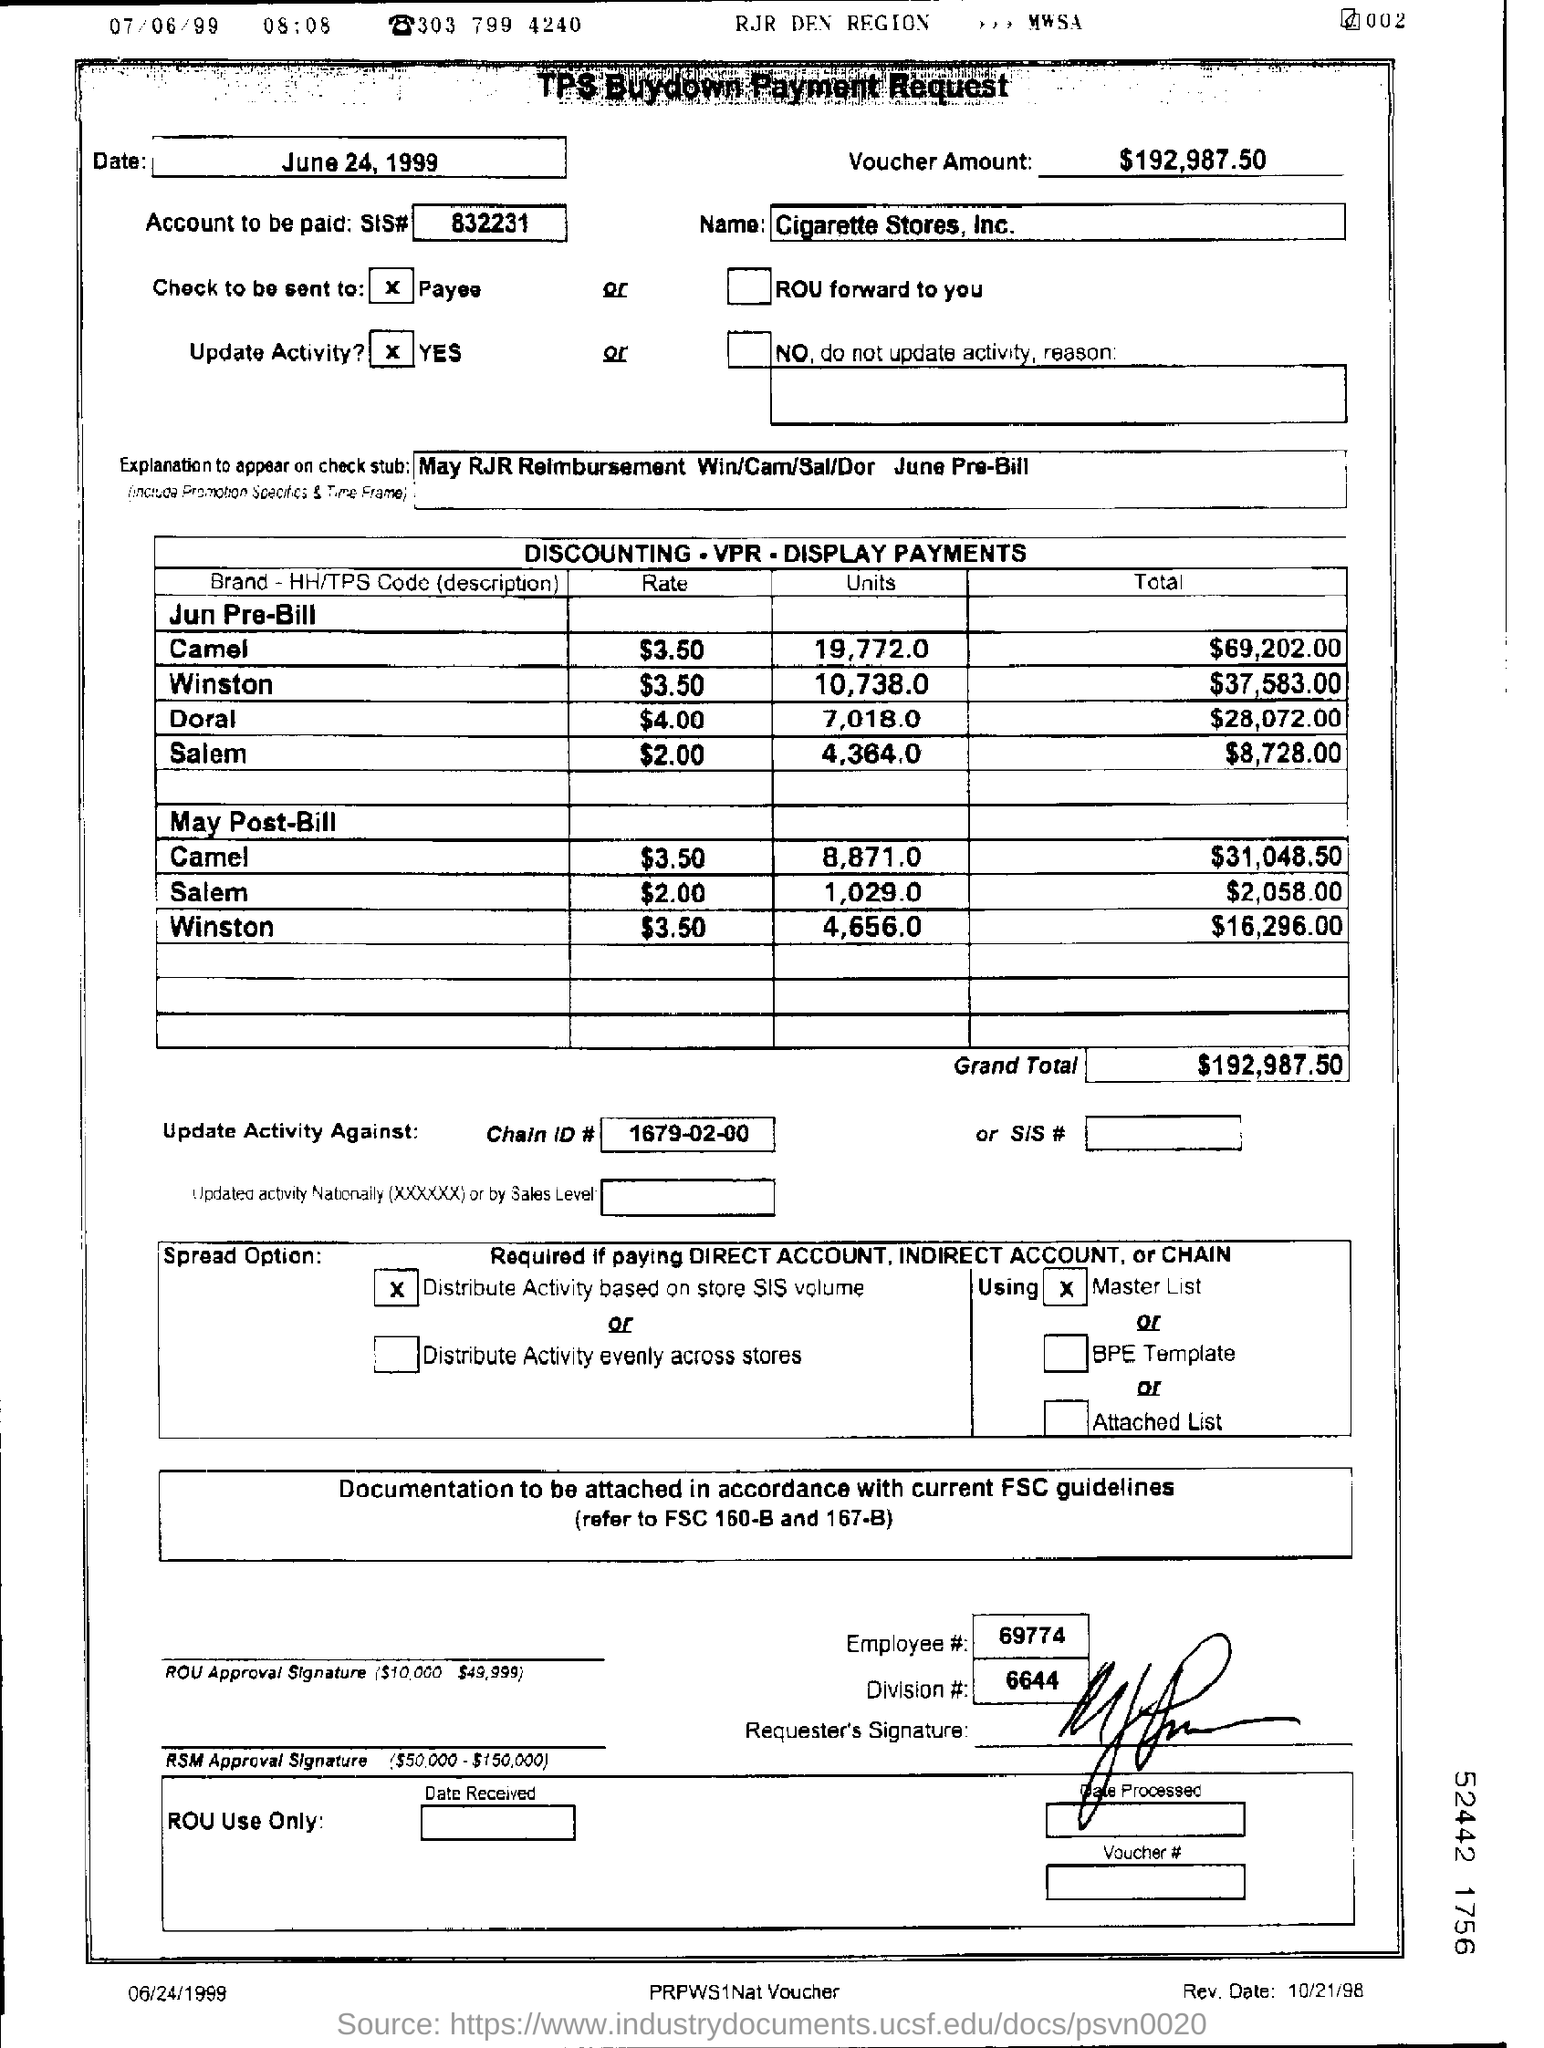Specify some key components in this picture. The grand total is $192,987.50. The chain ID is 1679-02-00. Could you please provide the division number of the requester, which is 6644? The date written on the top left box is June 24, 1999. What is the name of the corporation? It is Cigarette Stores, Inc. 